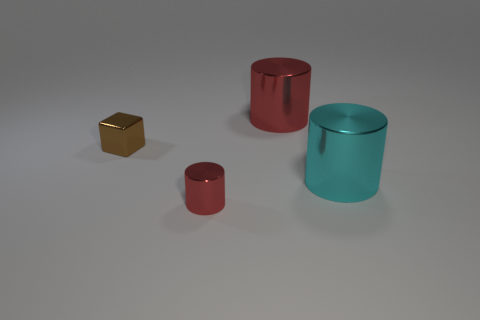Are there any other things that have the same color as the shiny cube?
Make the answer very short. No. There is another cylinder that is the same size as the cyan shiny cylinder; what is its color?
Ensure brevity in your answer.  Red. How big is the red shiny object in front of the brown metallic cube?
Offer a terse response. Small. Are there any tiny shiny objects left of the red shiny object behind the cyan object?
Ensure brevity in your answer.  Yes. Is the material of the small cube that is behind the big cyan cylinder the same as the small red object?
Your response must be concise. Yes. What number of cylinders are both to the left of the large cyan thing and in front of the small cube?
Keep it short and to the point. 1. What number of large cylinders are made of the same material as the tiny block?
Your answer should be compact. 2. What color is the cube that is made of the same material as the tiny cylinder?
Your answer should be very brief. Brown. Is the number of red cylinders less than the number of things?
Your answer should be compact. Yes. What is the small brown object made of?
Your answer should be very brief. Metal. 